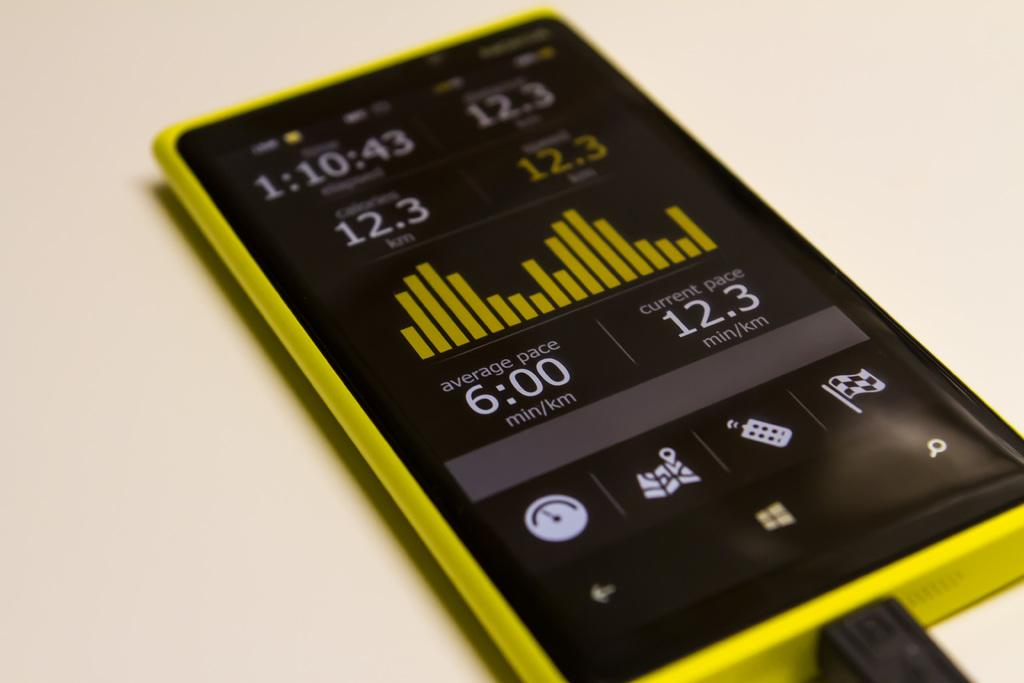<image>
Share a concise interpretation of the image provided. Yellow and black cellphone that has the time 1:10:43 on top. 